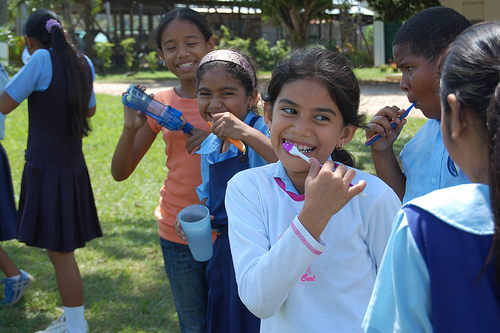Describe what the children are doing in the picture. The children are engaged in a playful outdoor toothbrushing session. A couple of girls are brushing their teeth, showing their commitment to dental hygiene in a fun way, while others look on or chat amiably. What do you think they might be talking about? They could be discussing their day at school, sharing dental care tips, or making plans for the rest of their day. Their expressions suggest a light and joyful conversation. 